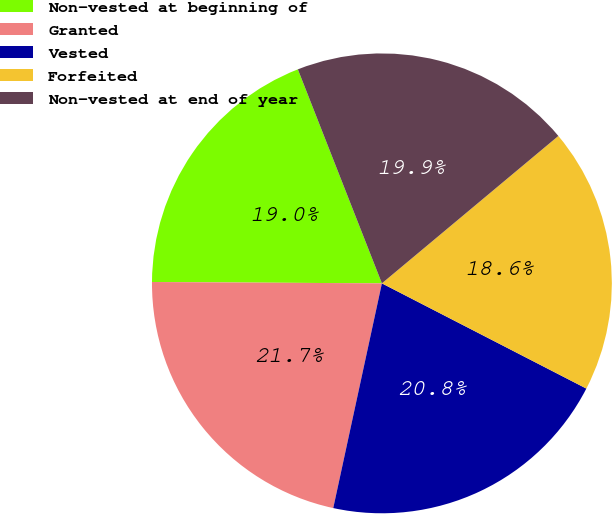Convert chart to OTSL. <chart><loc_0><loc_0><loc_500><loc_500><pie_chart><fcel>Non-vested at beginning of<fcel>Granted<fcel>Vested<fcel>Forfeited<fcel>Non-vested at end of year<nl><fcel>18.95%<fcel>21.7%<fcel>20.83%<fcel>18.64%<fcel>19.88%<nl></chart> 